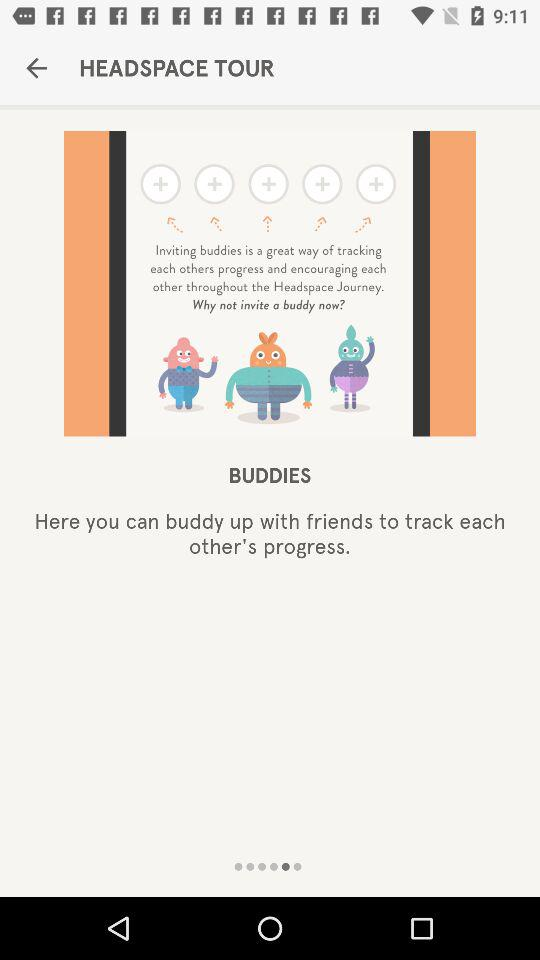What is the application name? The application name is "HEADSPACE TOUR". 